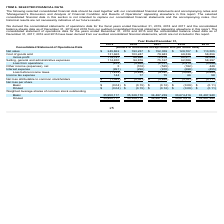From Freshpet's financial document, Which financial years' information is shown in the table? The document contains multiple relevant values: 2015, 2016, 2017, 2018, 2019. From the document: "2019 2018 2017 2016 2015 2019 2018 2017 2016 2015 2019 2018 2017 2016 2015 2019 2018 2017 2016 2015 2019 2018 2017 2016 2015..." Also, What are the 2 types of shares seen in the table? The document shows two values: Basic and Diluted. From the document: "Diluted $ (0.04) $ (0.15) $ (0.12) $ (0.09) $ (0.11) Basic $ (0.04) $ (0.15) $ (0.12) $ (0.09) $ (0.11)..." Also, What is the net loss per basic share as at each financial year end between 2015-2019 respectively? The document contains multiple relevant values: $(0.11), $(0.09), $(0.12), $(0.15), $(0.04). From the document: "Basic $ (0.04) $ (0.15) $ (0.12) $ (0.09) $ (0.11) Basic $ (0.04) $ (0.15) $ (0.12) $ (0.09) $ (0.11) Basic $ (0.04) $ (0.15) $ (0.12) $ (0.09) $ (0.1..." Also, can you calculate: What is the percentage change in net sales from 2018 to 2019? To answer this question, I need to perform calculations using the financial data. The calculation is: (245,862-193,237)/193,237, which equals 27.23 (percentage). This is based on the information: "Net sales $ 245,862 $ 193,237 $ 152,359 $ 129,707 $ 113,505 Net sales $ 245,862 $ 193,237 $ 152,359 $ 129,707 $ 113,505..." The key data points involved are: 193,237, 245,862. Also, can you calculate: What is the percentage change in cost of goods sold from 2018 to 2019? To answer this question, I need to perform calculations using the financial data. The calculation is: (131,665-103,247)/103,247, which equals 27.52 (percentage). This is based on the information: "Cost of goods sold 131,665 103,247 79,943 69,336 58,856 Cost of goods sold 131,665 103,247 79,943 69,336 58,856..." The key data points involved are: 103,247, 131,665. Also, can you calculate: What is the percentage change in gross profit from 2018 to 2019 year end? To answer this question, I need to perform calculations using the financial data. The calculation is: (114,197-89,990)/89,990, which equals 26.9 (percentage). This is based on the information: "Gross profit 114,197 89,990 72,416 60,371 54,649 Gross profit 114,197 89,990 72,416 60,371 54,649..." The key data points involved are: 114,197, 89,990. 